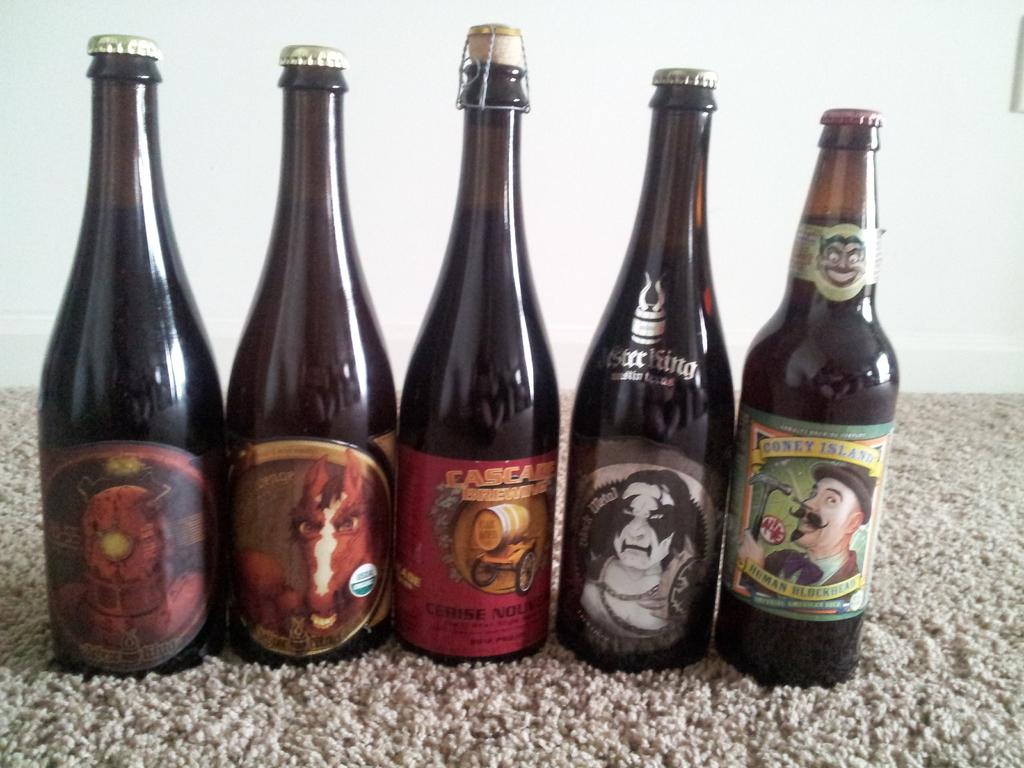What object can be seen in the image that is typically used for holding liquids? There is a bottle in the image. What type of item is present on the floor in the image? There is a floor mat in the image. How many crows are sitting on the bulb in the image? There are no crows or bulbs present in the image. What causes the bottle to burst in the image? There is no indication of the bottle bursting in the image. 